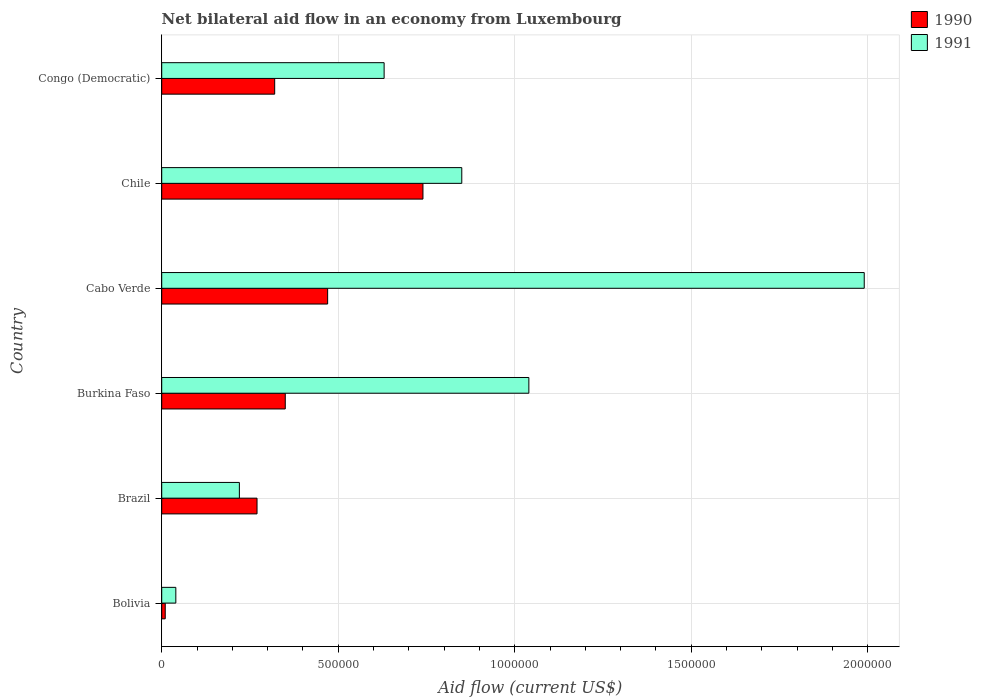Are the number of bars on each tick of the Y-axis equal?
Keep it short and to the point. Yes. What is the label of the 4th group of bars from the top?
Offer a very short reply. Burkina Faso. What is the net bilateral aid flow in 1990 in Brazil?
Your answer should be compact. 2.70e+05. Across all countries, what is the maximum net bilateral aid flow in 1991?
Offer a very short reply. 1.99e+06. Across all countries, what is the minimum net bilateral aid flow in 1990?
Give a very brief answer. 10000. In which country was the net bilateral aid flow in 1991 maximum?
Keep it short and to the point. Cabo Verde. In which country was the net bilateral aid flow in 1990 minimum?
Your response must be concise. Bolivia. What is the total net bilateral aid flow in 1990 in the graph?
Ensure brevity in your answer.  2.16e+06. What is the difference between the net bilateral aid flow in 1991 in Congo (Democratic) and the net bilateral aid flow in 1990 in Bolivia?
Make the answer very short. 6.20e+05. What is the average net bilateral aid flow in 1991 per country?
Offer a very short reply. 7.95e+05. What is the difference between the net bilateral aid flow in 1991 and net bilateral aid flow in 1990 in Chile?
Keep it short and to the point. 1.10e+05. What is the ratio of the net bilateral aid flow in 1990 in Brazil to that in Chile?
Provide a succinct answer. 0.36. Is the difference between the net bilateral aid flow in 1991 in Bolivia and Chile greater than the difference between the net bilateral aid flow in 1990 in Bolivia and Chile?
Make the answer very short. No. What is the difference between the highest and the lowest net bilateral aid flow in 1990?
Keep it short and to the point. 7.30e+05. How many bars are there?
Ensure brevity in your answer.  12. Are all the bars in the graph horizontal?
Give a very brief answer. Yes. What is the difference between two consecutive major ticks on the X-axis?
Give a very brief answer. 5.00e+05. Are the values on the major ticks of X-axis written in scientific E-notation?
Your response must be concise. No. Does the graph contain any zero values?
Provide a short and direct response. No. What is the title of the graph?
Offer a terse response. Net bilateral aid flow in an economy from Luxembourg. Does "1998" appear as one of the legend labels in the graph?
Ensure brevity in your answer.  No. What is the label or title of the Y-axis?
Your answer should be very brief. Country. What is the Aid flow (current US$) of 1990 in Brazil?
Offer a very short reply. 2.70e+05. What is the Aid flow (current US$) of 1991 in Brazil?
Offer a terse response. 2.20e+05. What is the Aid flow (current US$) in 1990 in Burkina Faso?
Ensure brevity in your answer.  3.50e+05. What is the Aid flow (current US$) of 1991 in Burkina Faso?
Your response must be concise. 1.04e+06. What is the Aid flow (current US$) in 1991 in Cabo Verde?
Provide a succinct answer. 1.99e+06. What is the Aid flow (current US$) in 1990 in Chile?
Keep it short and to the point. 7.40e+05. What is the Aid flow (current US$) in 1991 in Chile?
Offer a very short reply. 8.50e+05. What is the Aid flow (current US$) of 1991 in Congo (Democratic)?
Offer a terse response. 6.30e+05. Across all countries, what is the maximum Aid flow (current US$) of 1990?
Your answer should be compact. 7.40e+05. Across all countries, what is the maximum Aid flow (current US$) of 1991?
Offer a very short reply. 1.99e+06. Across all countries, what is the minimum Aid flow (current US$) of 1991?
Provide a short and direct response. 4.00e+04. What is the total Aid flow (current US$) of 1990 in the graph?
Keep it short and to the point. 2.16e+06. What is the total Aid flow (current US$) in 1991 in the graph?
Your answer should be very brief. 4.77e+06. What is the difference between the Aid flow (current US$) in 1990 in Bolivia and that in Brazil?
Your answer should be compact. -2.60e+05. What is the difference between the Aid flow (current US$) of 1990 in Bolivia and that in Burkina Faso?
Your answer should be very brief. -3.40e+05. What is the difference between the Aid flow (current US$) of 1990 in Bolivia and that in Cabo Verde?
Ensure brevity in your answer.  -4.60e+05. What is the difference between the Aid flow (current US$) in 1991 in Bolivia and that in Cabo Verde?
Ensure brevity in your answer.  -1.95e+06. What is the difference between the Aid flow (current US$) of 1990 in Bolivia and that in Chile?
Your answer should be compact. -7.30e+05. What is the difference between the Aid flow (current US$) of 1991 in Bolivia and that in Chile?
Give a very brief answer. -8.10e+05. What is the difference between the Aid flow (current US$) of 1990 in Bolivia and that in Congo (Democratic)?
Provide a succinct answer. -3.10e+05. What is the difference between the Aid flow (current US$) in 1991 in Bolivia and that in Congo (Democratic)?
Provide a short and direct response. -5.90e+05. What is the difference between the Aid flow (current US$) in 1991 in Brazil and that in Burkina Faso?
Offer a terse response. -8.20e+05. What is the difference between the Aid flow (current US$) in 1990 in Brazil and that in Cabo Verde?
Ensure brevity in your answer.  -2.00e+05. What is the difference between the Aid flow (current US$) of 1991 in Brazil and that in Cabo Verde?
Provide a short and direct response. -1.77e+06. What is the difference between the Aid flow (current US$) of 1990 in Brazil and that in Chile?
Offer a very short reply. -4.70e+05. What is the difference between the Aid flow (current US$) of 1991 in Brazil and that in Chile?
Give a very brief answer. -6.30e+05. What is the difference between the Aid flow (current US$) in 1991 in Brazil and that in Congo (Democratic)?
Provide a succinct answer. -4.10e+05. What is the difference between the Aid flow (current US$) of 1991 in Burkina Faso and that in Cabo Verde?
Provide a succinct answer. -9.50e+05. What is the difference between the Aid flow (current US$) in 1990 in Burkina Faso and that in Chile?
Offer a terse response. -3.90e+05. What is the difference between the Aid flow (current US$) of 1990 in Cabo Verde and that in Chile?
Give a very brief answer. -2.70e+05. What is the difference between the Aid flow (current US$) of 1991 in Cabo Verde and that in Chile?
Provide a succinct answer. 1.14e+06. What is the difference between the Aid flow (current US$) of 1991 in Cabo Verde and that in Congo (Democratic)?
Provide a short and direct response. 1.36e+06. What is the difference between the Aid flow (current US$) in 1990 in Chile and that in Congo (Democratic)?
Ensure brevity in your answer.  4.20e+05. What is the difference between the Aid flow (current US$) in 1990 in Bolivia and the Aid flow (current US$) in 1991 in Brazil?
Ensure brevity in your answer.  -2.10e+05. What is the difference between the Aid flow (current US$) in 1990 in Bolivia and the Aid flow (current US$) in 1991 in Burkina Faso?
Offer a very short reply. -1.03e+06. What is the difference between the Aid flow (current US$) in 1990 in Bolivia and the Aid flow (current US$) in 1991 in Cabo Verde?
Your answer should be compact. -1.98e+06. What is the difference between the Aid flow (current US$) of 1990 in Bolivia and the Aid flow (current US$) of 1991 in Chile?
Offer a very short reply. -8.40e+05. What is the difference between the Aid flow (current US$) in 1990 in Bolivia and the Aid flow (current US$) in 1991 in Congo (Democratic)?
Provide a short and direct response. -6.20e+05. What is the difference between the Aid flow (current US$) of 1990 in Brazil and the Aid flow (current US$) of 1991 in Burkina Faso?
Provide a succinct answer. -7.70e+05. What is the difference between the Aid flow (current US$) in 1990 in Brazil and the Aid flow (current US$) in 1991 in Cabo Verde?
Provide a short and direct response. -1.72e+06. What is the difference between the Aid flow (current US$) of 1990 in Brazil and the Aid flow (current US$) of 1991 in Chile?
Your answer should be compact. -5.80e+05. What is the difference between the Aid flow (current US$) in 1990 in Brazil and the Aid flow (current US$) in 1991 in Congo (Democratic)?
Provide a succinct answer. -3.60e+05. What is the difference between the Aid flow (current US$) in 1990 in Burkina Faso and the Aid flow (current US$) in 1991 in Cabo Verde?
Offer a very short reply. -1.64e+06. What is the difference between the Aid flow (current US$) in 1990 in Burkina Faso and the Aid flow (current US$) in 1991 in Chile?
Provide a succinct answer. -5.00e+05. What is the difference between the Aid flow (current US$) of 1990 in Burkina Faso and the Aid flow (current US$) of 1991 in Congo (Democratic)?
Offer a terse response. -2.80e+05. What is the difference between the Aid flow (current US$) of 1990 in Cabo Verde and the Aid flow (current US$) of 1991 in Chile?
Provide a short and direct response. -3.80e+05. What is the average Aid flow (current US$) in 1991 per country?
Your response must be concise. 7.95e+05. What is the difference between the Aid flow (current US$) of 1990 and Aid flow (current US$) of 1991 in Bolivia?
Your answer should be compact. -3.00e+04. What is the difference between the Aid flow (current US$) in 1990 and Aid flow (current US$) in 1991 in Brazil?
Provide a short and direct response. 5.00e+04. What is the difference between the Aid flow (current US$) of 1990 and Aid flow (current US$) of 1991 in Burkina Faso?
Make the answer very short. -6.90e+05. What is the difference between the Aid flow (current US$) of 1990 and Aid flow (current US$) of 1991 in Cabo Verde?
Offer a very short reply. -1.52e+06. What is the difference between the Aid flow (current US$) in 1990 and Aid flow (current US$) in 1991 in Chile?
Your answer should be compact. -1.10e+05. What is the difference between the Aid flow (current US$) of 1990 and Aid flow (current US$) of 1991 in Congo (Democratic)?
Keep it short and to the point. -3.10e+05. What is the ratio of the Aid flow (current US$) of 1990 in Bolivia to that in Brazil?
Provide a short and direct response. 0.04. What is the ratio of the Aid flow (current US$) of 1991 in Bolivia to that in Brazil?
Your response must be concise. 0.18. What is the ratio of the Aid flow (current US$) in 1990 in Bolivia to that in Burkina Faso?
Ensure brevity in your answer.  0.03. What is the ratio of the Aid flow (current US$) of 1991 in Bolivia to that in Burkina Faso?
Offer a very short reply. 0.04. What is the ratio of the Aid flow (current US$) of 1990 in Bolivia to that in Cabo Verde?
Make the answer very short. 0.02. What is the ratio of the Aid flow (current US$) in 1991 in Bolivia to that in Cabo Verde?
Provide a short and direct response. 0.02. What is the ratio of the Aid flow (current US$) of 1990 in Bolivia to that in Chile?
Provide a succinct answer. 0.01. What is the ratio of the Aid flow (current US$) of 1991 in Bolivia to that in Chile?
Make the answer very short. 0.05. What is the ratio of the Aid flow (current US$) of 1990 in Bolivia to that in Congo (Democratic)?
Provide a short and direct response. 0.03. What is the ratio of the Aid flow (current US$) in 1991 in Bolivia to that in Congo (Democratic)?
Offer a terse response. 0.06. What is the ratio of the Aid flow (current US$) in 1990 in Brazil to that in Burkina Faso?
Make the answer very short. 0.77. What is the ratio of the Aid flow (current US$) of 1991 in Brazil to that in Burkina Faso?
Your answer should be very brief. 0.21. What is the ratio of the Aid flow (current US$) in 1990 in Brazil to that in Cabo Verde?
Give a very brief answer. 0.57. What is the ratio of the Aid flow (current US$) of 1991 in Brazil to that in Cabo Verde?
Keep it short and to the point. 0.11. What is the ratio of the Aid flow (current US$) of 1990 in Brazil to that in Chile?
Keep it short and to the point. 0.36. What is the ratio of the Aid flow (current US$) of 1991 in Brazil to that in Chile?
Provide a succinct answer. 0.26. What is the ratio of the Aid flow (current US$) in 1990 in Brazil to that in Congo (Democratic)?
Provide a succinct answer. 0.84. What is the ratio of the Aid flow (current US$) in 1991 in Brazil to that in Congo (Democratic)?
Provide a succinct answer. 0.35. What is the ratio of the Aid flow (current US$) in 1990 in Burkina Faso to that in Cabo Verde?
Ensure brevity in your answer.  0.74. What is the ratio of the Aid flow (current US$) in 1991 in Burkina Faso to that in Cabo Verde?
Offer a very short reply. 0.52. What is the ratio of the Aid flow (current US$) of 1990 in Burkina Faso to that in Chile?
Make the answer very short. 0.47. What is the ratio of the Aid flow (current US$) in 1991 in Burkina Faso to that in Chile?
Give a very brief answer. 1.22. What is the ratio of the Aid flow (current US$) of 1990 in Burkina Faso to that in Congo (Democratic)?
Your response must be concise. 1.09. What is the ratio of the Aid flow (current US$) of 1991 in Burkina Faso to that in Congo (Democratic)?
Keep it short and to the point. 1.65. What is the ratio of the Aid flow (current US$) of 1990 in Cabo Verde to that in Chile?
Offer a very short reply. 0.64. What is the ratio of the Aid flow (current US$) of 1991 in Cabo Verde to that in Chile?
Provide a short and direct response. 2.34. What is the ratio of the Aid flow (current US$) of 1990 in Cabo Verde to that in Congo (Democratic)?
Offer a terse response. 1.47. What is the ratio of the Aid flow (current US$) in 1991 in Cabo Verde to that in Congo (Democratic)?
Ensure brevity in your answer.  3.16. What is the ratio of the Aid flow (current US$) in 1990 in Chile to that in Congo (Democratic)?
Provide a succinct answer. 2.31. What is the ratio of the Aid flow (current US$) of 1991 in Chile to that in Congo (Democratic)?
Provide a short and direct response. 1.35. What is the difference between the highest and the second highest Aid flow (current US$) in 1990?
Your answer should be compact. 2.70e+05. What is the difference between the highest and the second highest Aid flow (current US$) of 1991?
Offer a terse response. 9.50e+05. What is the difference between the highest and the lowest Aid flow (current US$) of 1990?
Provide a short and direct response. 7.30e+05. What is the difference between the highest and the lowest Aid flow (current US$) of 1991?
Offer a very short reply. 1.95e+06. 